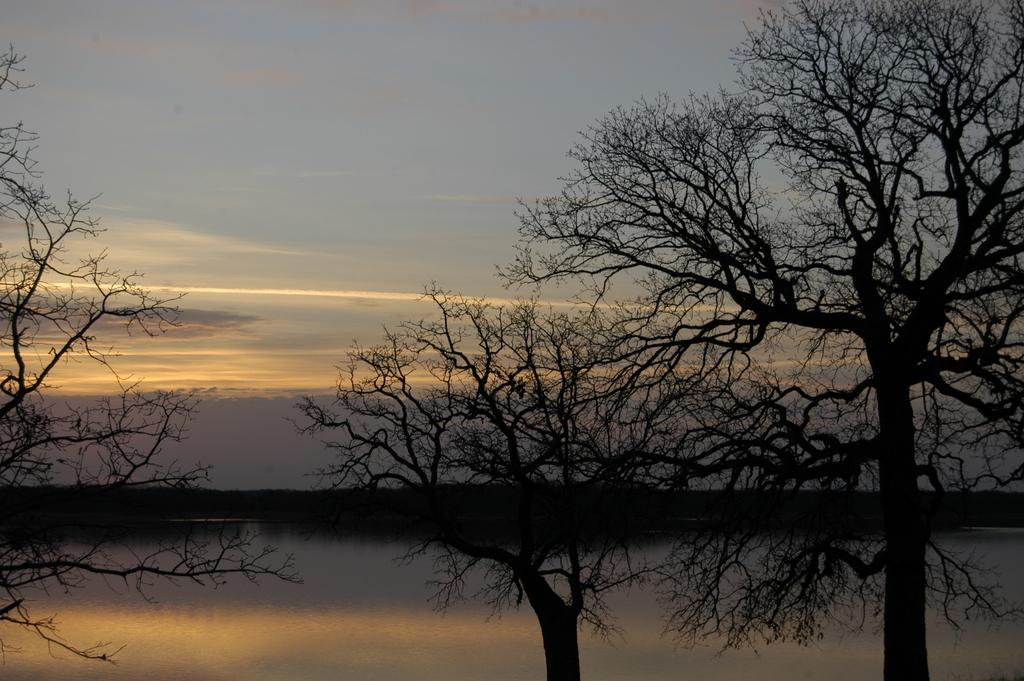What type of vegetation can be seen in the image? There are trees in the image. What is present at the bottom side of the image? There appears to be water at the bottom side of the image. What can be seen in the background of the image? There is greenery in the background area of the image. What type of pickle can be seen floating in the water in the image? There is no pickle present in the image; it features trees and water. Can you describe the smell of the jellyfish in the image? There is no jellyfish present in the image, so it is not possible to describe its smell. 